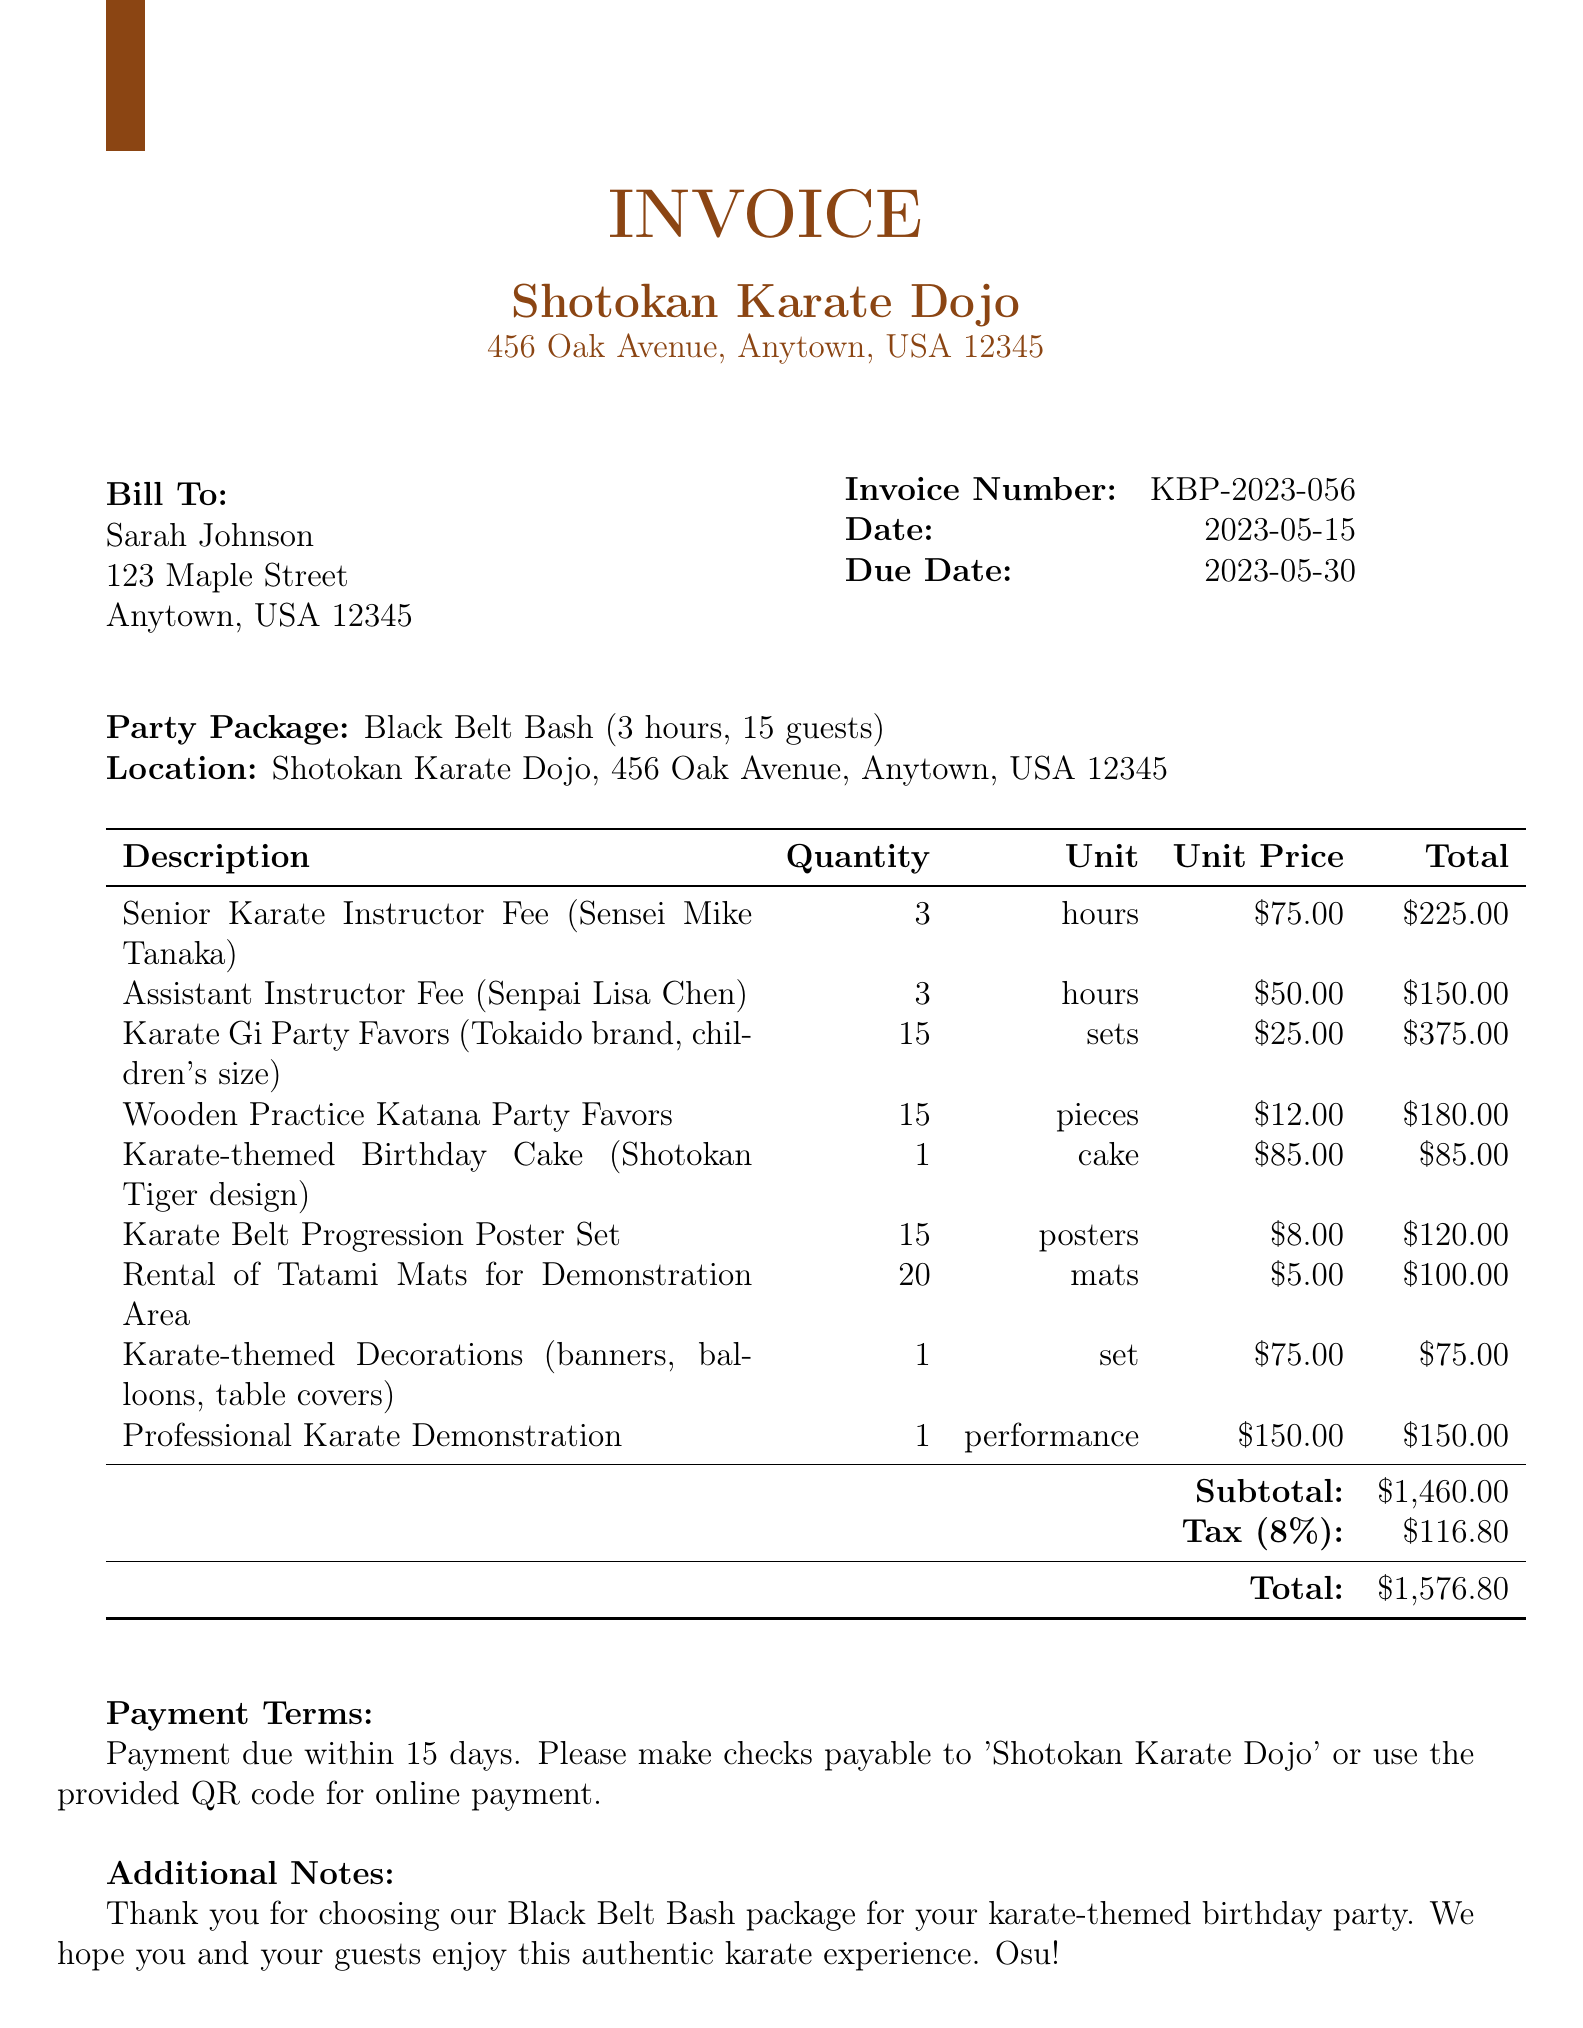What is the invoice number? The invoice number is clearly stated in the document and is a unique identifier for the invoice.
Answer: KBP-2023-056 What is the total amount due? The total amount due is calculated by adding the subtotal and tax amount, which is explicitly mentioned in the document.
Answer: $1,576.80 Who is the senior karate instructor? The document specifies the instructor's name, which is needed to identify the person providing the service.
Answer: Sensei Mike Tanaka What is the quantity of Karate Gi Party Favors? The number of karate gi party favors is outlined as part of the line items in the invoice.
Answer: 15 How many guests are included in the party package? The document outlines the number of guests for whom the package is designed, providing key information about the service provided.
Answer: 15 What is the tax rate applied to the invoice? The tax rate is stated explicitly in the invoice and is necessary for understanding the total cost.
Answer: 8% What type of cake is included in the package? The cake description is provided in the line items and is a specific detail about one of the offerings in the package.
Answer: Shotokan Tiger design What does the payment term say? The payment terms specify how the payment should be made, which is essential for the receiver of the invoice.
Answer: Payment due within 15 days How long is the duration of the party package? The duration is an important detail about the service being provided and is specified in the invoice.
Answer: 3 hours 